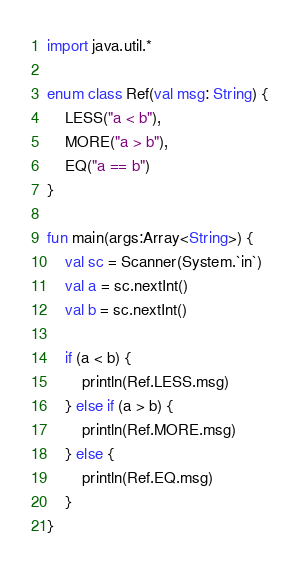<code> <loc_0><loc_0><loc_500><loc_500><_Kotlin_>import java.util.*

enum class Ref(val msg: String) {
    LESS("a < b"),
    MORE("a > b"),
    EQ("a == b")
}

fun main(args:Array<String>) {
    val sc = Scanner(System.`in`)
    val a = sc.nextInt()
    val b = sc.nextInt()

    if (a < b) {
        println(Ref.LESS.msg)
    } else if (a > b) {
        println(Ref.MORE.msg)
    } else {
        println(Ref.EQ.msg)
    }
}
</code> 